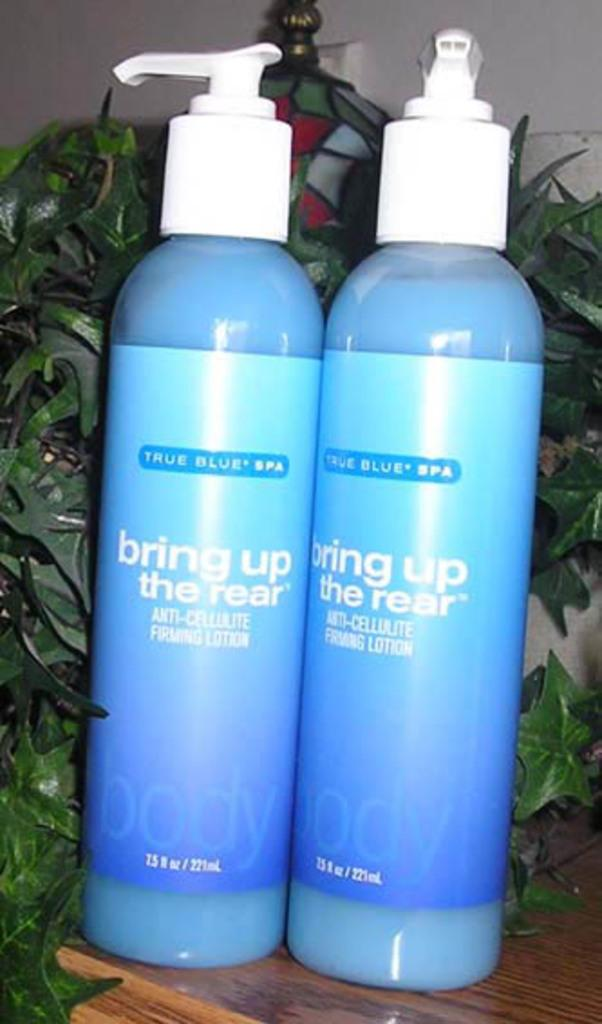What is located in the foreground of the picture? There are blue color bottles in the foreground of the picture. What is the bottles resting on? The bottles are on a wooden object. What can be seen in the middle of the picture? There is greenery in the middle of the picture, possibly consisting of plants. What structure is visible at the top of the image? There is a well at the top of the image. How many roses are being distributed by the person in the image? There is no person or roses present in the image. 